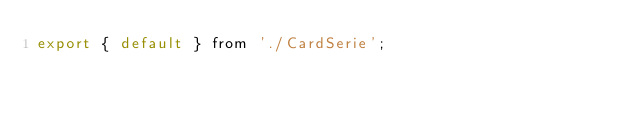Convert code to text. <code><loc_0><loc_0><loc_500><loc_500><_JavaScript_>export { default } from './CardSerie';
</code> 